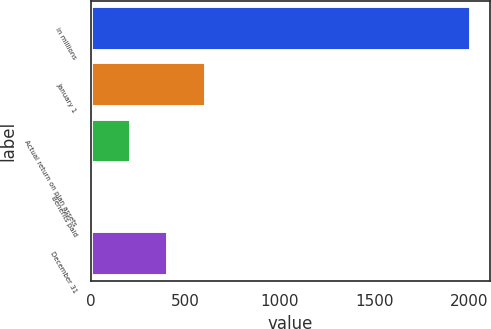Convert chart to OTSL. <chart><loc_0><loc_0><loc_500><loc_500><bar_chart><fcel>in millions<fcel>January 1<fcel>Actual return on plan assets<fcel>Benefits paid<fcel>December 31<nl><fcel>2008<fcel>609.33<fcel>209.71<fcel>9.9<fcel>409.52<nl></chart> 